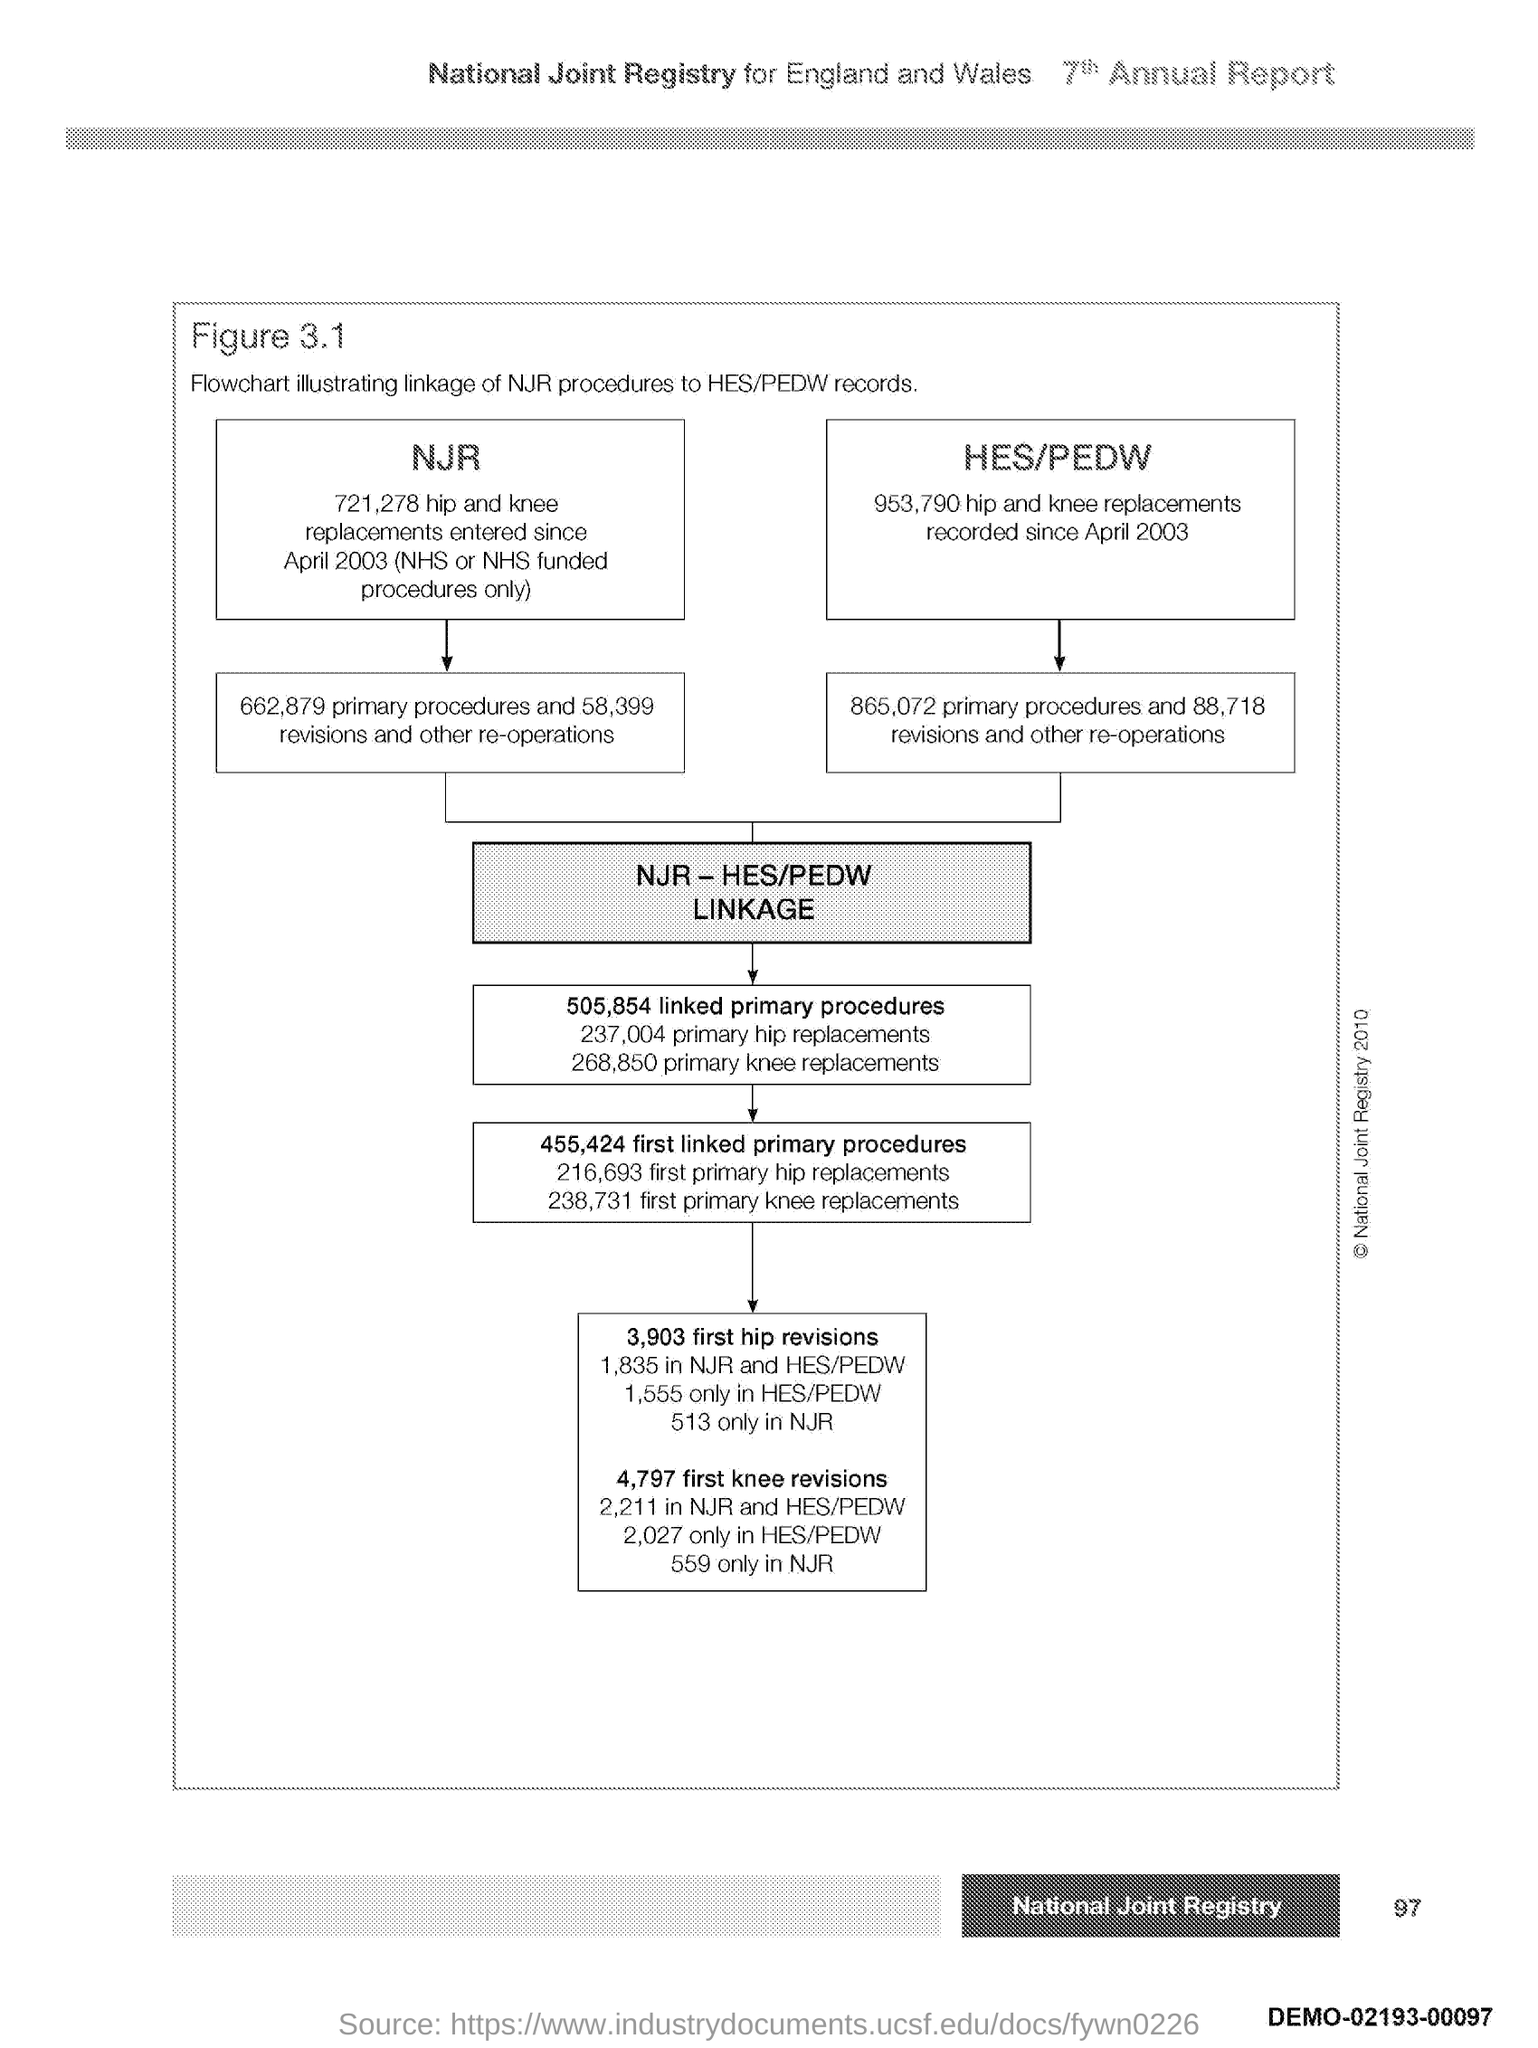Indicate a few pertinent items in this graphic. The page number is 97. 